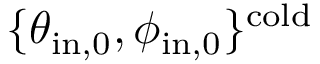<formula> <loc_0><loc_0><loc_500><loc_500>\{ \theta _ { i n , 0 } , \phi _ { i n , 0 } \} ^ { c o l d }</formula> 